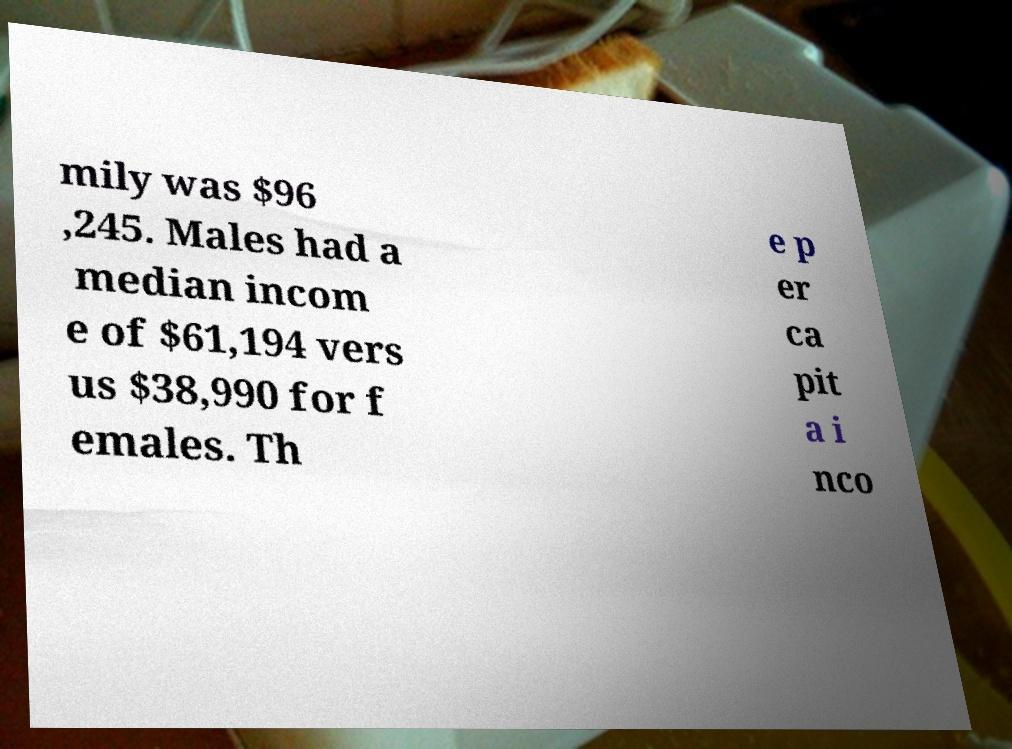Please read and relay the text visible in this image. What does it say? mily was $96 ,245. Males had a median incom e of $61,194 vers us $38,990 for f emales. Th e p er ca pit a i nco 